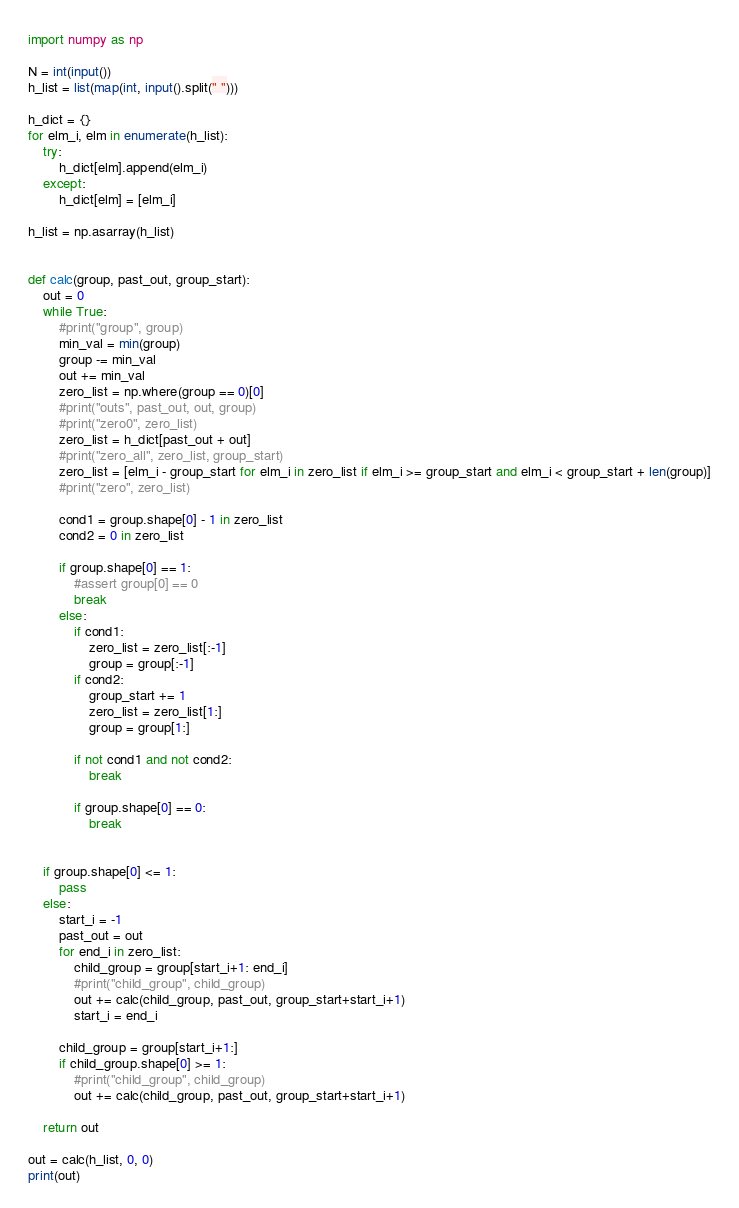Convert code to text. <code><loc_0><loc_0><loc_500><loc_500><_Python_>import numpy as np

N = int(input())
h_list = list(map(int, input().split(" ")))

h_dict = {}
for elm_i, elm in enumerate(h_list):
    try:
        h_dict[elm].append(elm_i)
    except:
        h_dict[elm] = [elm_i]

h_list = np.asarray(h_list)


def calc(group, past_out, group_start):
    out = 0
    while True:
        #print("group", group)
        min_val = min(group)
        group -= min_val
        out += min_val
        zero_list = np.where(group == 0)[0]
        #print("outs", past_out, out, group)
        #print("zero0", zero_list)
        zero_list = h_dict[past_out + out]
        #print("zero_all", zero_list, group_start)
        zero_list = [elm_i - group_start for elm_i in zero_list if elm_i >= group_start and elm_i < group_start + len(group)]
        #print("zero", zero_list)

        cond1 = group.shape[0] - 1 in zero_list
        cond2 = 0 in zero_list

        if group.shape[0] == 1:
            #assert group[0] == 0
            break
        else:
            if cond1: 
                zero_list = zero_list[:-1]
                group = group[:-1]
            if cond2:
                group_start += 1
                zero_list = zero_list[1:]
                group = group[1:]

            if not cond1 and not cond2:
                break

            if group.shape[0] == 0:
                break


    if group.shape[0] <= 1:
        pass
    else:
        start_i = -1
        past_out = out
        for end_i in zero_list:
            child_group = group[start_i+1: end_i]
            #print("child_group", child_group)
            out += calc(child_group, past_out, group_start+start_i+1)
            start_i = end_i

        child_group = group[start_i+1:]
        if child_group.shape[0] >= 1:
            #print("child_group", child_group)
            out += calc(child_group, past_out, group_start+start_i+1)

    return out

out = calc(h_list, 0, 0)
print(out)</code> 